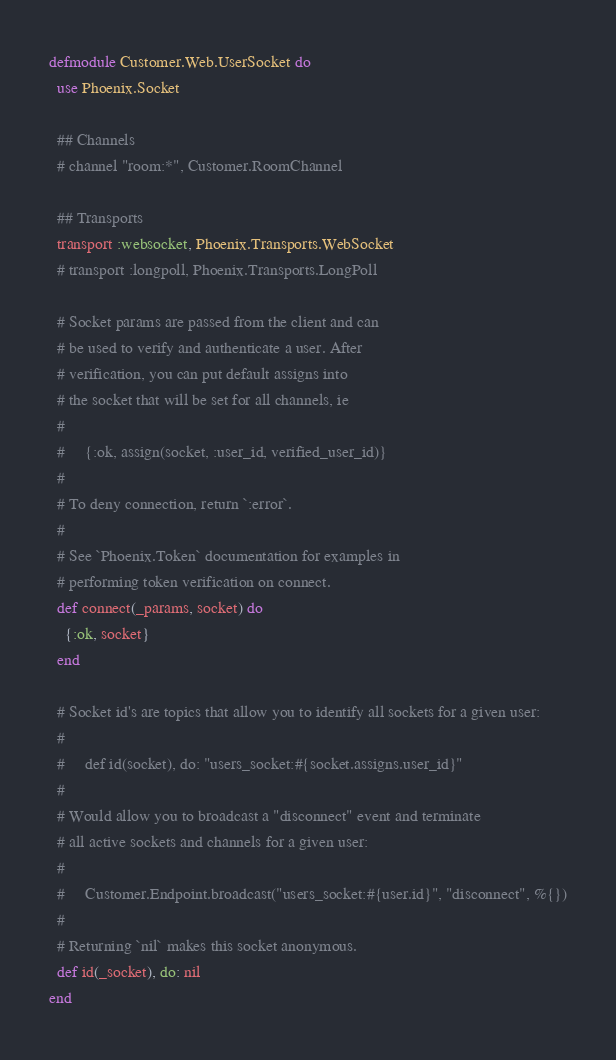Convert code to text. <code><loc_0><loc_0><loc_500><loc_500><_Elixir_>defmodule Customer.Web.UserSocket do
  use Phoenix.Socket

  ## Channels
  # channel "room:*", Customer.RoomChannel

  ## Transports
  transport :websocket, Phoenix.Transports.WebSocket
  # transport :longpoll, Phoenix.Transports.LongPoll

  # Socket params are passed from the client and can
  # be used to verify and authenticate a user. After
  # verification, you can put default assigns into
  # the socket that will be set for all channels, ie
  #
  #     {:ok, assign(socket, :user_id, verified_user_id)}
  #
  # To deny connection, return `:error`.
  #
  # See `Phoenix.Token` documentation for examples in
  # performing token verification on connect.
  def connect(_params, socket) do
    {:ok, socket}
  end

  # Socket id's are topics that allow you to identify all sockets for a given user:
  #
  #     def id(socket), do: "users_socket:#{socket.assigns.user_id}"
  #
  # Would allow you to broadcast a "disconnect" event and terminate
  # all active sockets and channels for a given user:
  #
  #     Customer.Endpoint.broadcast("users_socket:#{user.id}", "disconnect", %{})
  #
  # Returning `nil` makes this socket anonymous.
  def id(_socket), do: nil
end
</code> 